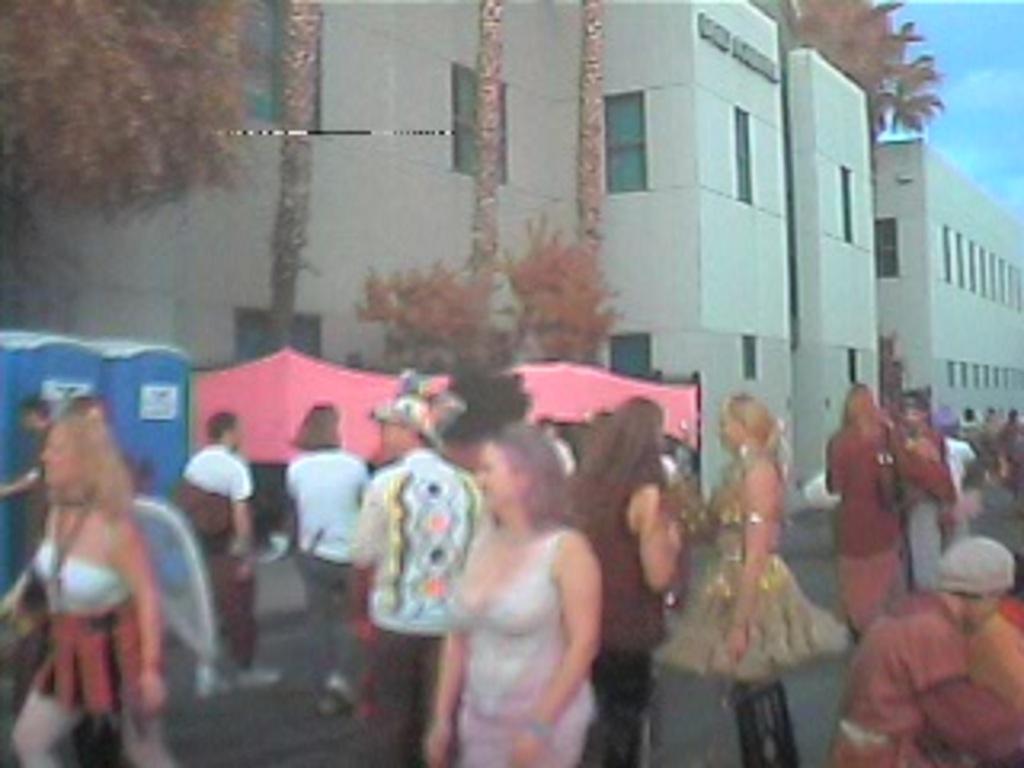How would you summarize this image in a sentence or two? In this image, I can see a group of people standing on the road. In the background, there are tents, readymade toilet cabins, trees, buildings and the sky. 